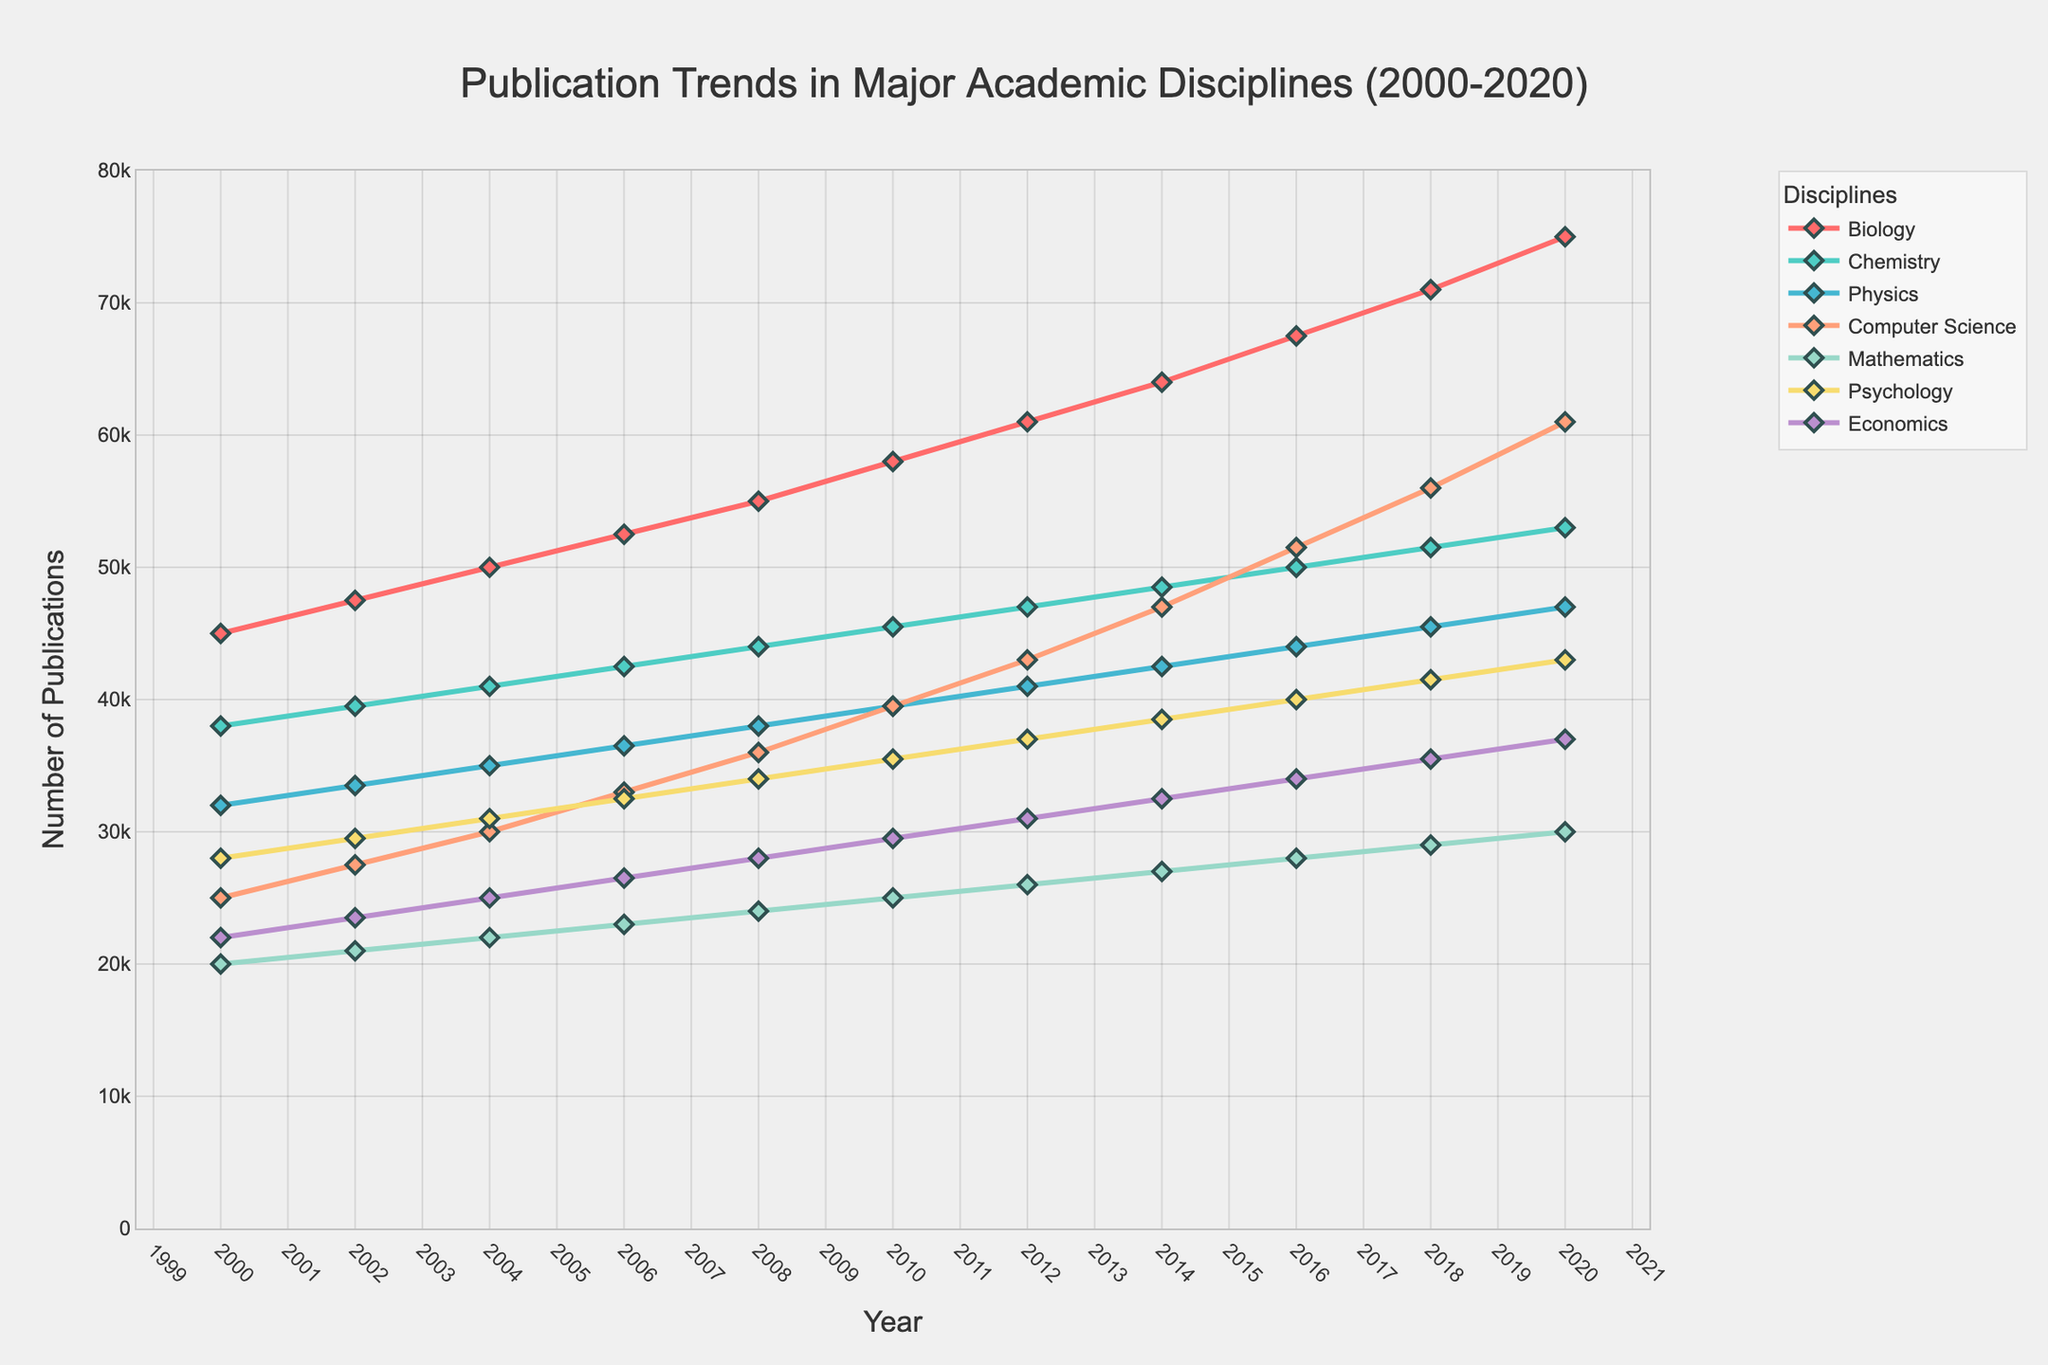What is the trend in the number of publications for Computer Science between 2000 and 2020? The publication count for Computer Science increases steadily over the years. In 2000, it starts at 25,000 and reaches 61,000 by 2020, indicating consistent growth.
Answer: It shows a steady increase Which discipline saw the highest number of publications in 2020? By looking at the endpoints of each line for the year 2020, the line representing Biology reaches the highest value.
Answer: Biology What is the difference in the number of publications between Computer Science and Mathematics in 2020? In 2020, Computer Science has 61,000 publications, while Mathematics has 30,000. Subtracting the two gives 61,000 - 30,000.
Answer: 31,000 Which discipline had the lowest number of publications in 2000? By examining the starting points of each line for the year 2000, Mathematics is the lowest with 20,000 publications.
Answer: Mathematics Between 2000 and 2020, which discipline saw the highest overall increase in the number of publications? Subtract the number of publications in 2000 from 2020 for each discipline and see which has the highest positive difference. Biology starts at 45,000 and ends at 75,000, a difference of 30,000, which is the highest increase.
Answer: Biology What is the average annual growth rate of publications in Psychology from 2000 to 2020? The number of publications in Psychology in 2000 is 28,000 and in 2020 it is 43,000. The increase is 43,000 - 28,000 = 15,000. Dividing this by the number of years (20) gives the average annual growth rate as 15,000 / 20.
Answer: 750 How do the trends of publications in Chemistry and Physics compare over the two decades? Both Chemistry and Physics show a steady upward trend, but Chemistry consistently has a higher number of publications compared to Physics throughout the two decades, with both showing substantial growth.
Answer: Chemistry consistently higher than Physics What is the sum of publications in Economics and Psychology in 2016? In 2016, Economics has 34,000 publications and Psychology has 40,000. Adding these, we get 34,000 + 40,000.
Answer: 74,000 In which year does Computer Science surpass Physics in terms of publication count? Following the earlier publication trends, Computer Science surpasses Physics in 2010 where both intersect and Computer Science continues over Physics after that.
Answer: 2010 Which discipline saw a steady, consistent linear increase without any noticeable dips or sudden jumps? Computer Science shows a steady linear increase from 25,000 in 2000 to 61,000 in 2020 without any visible dips or jumps in the trend.
Answer: Computer Science 